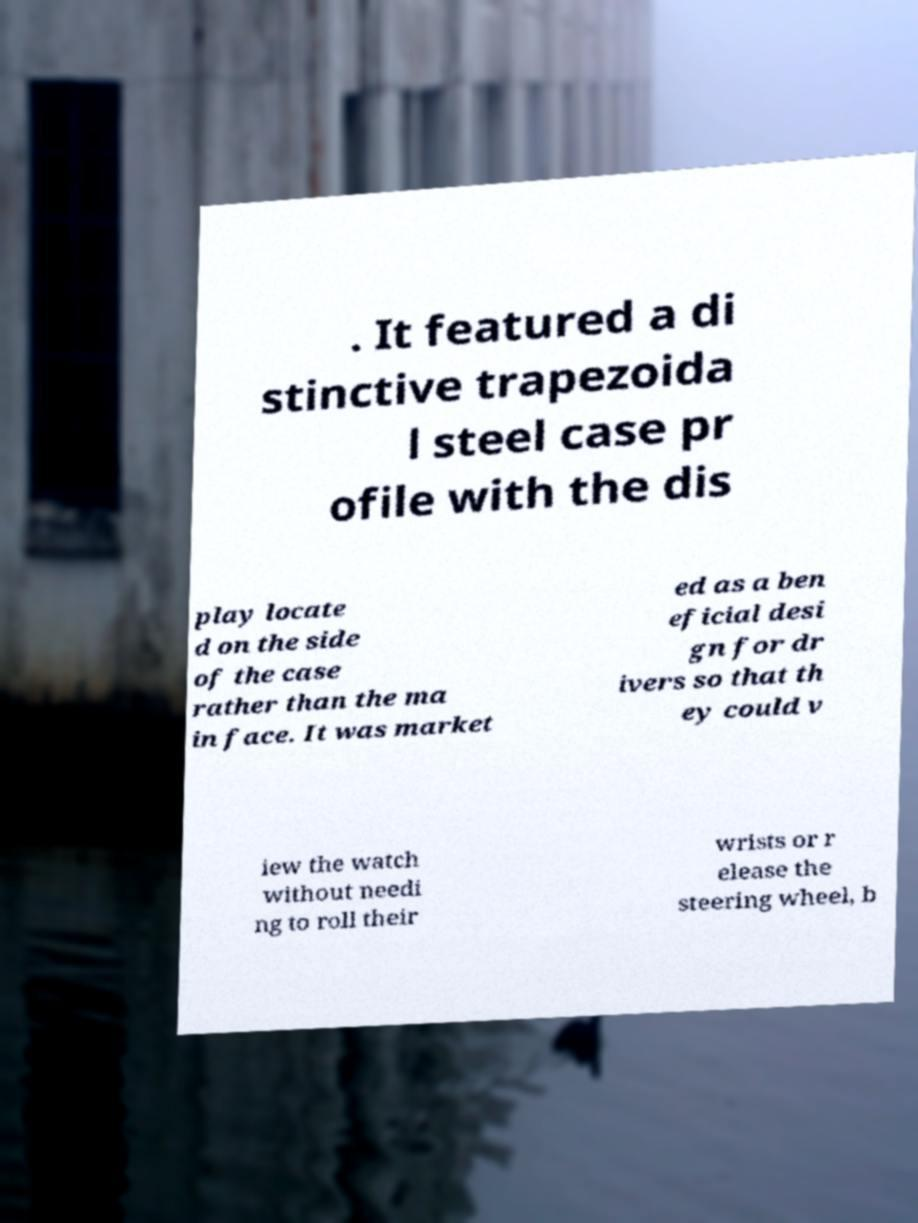For documentation purposes, I need the text within this image transcribed. Could you provide that? . It featured a di stinctive trapezoida l steel case pr ofile with the dis play locate d on the side of the case rather than the ma in face. It was market ed as a ben eficial desi gn for dr ivers so that th ey could v iew the watch without needi ng to roll their wrists or r elease the steering wheel, b 